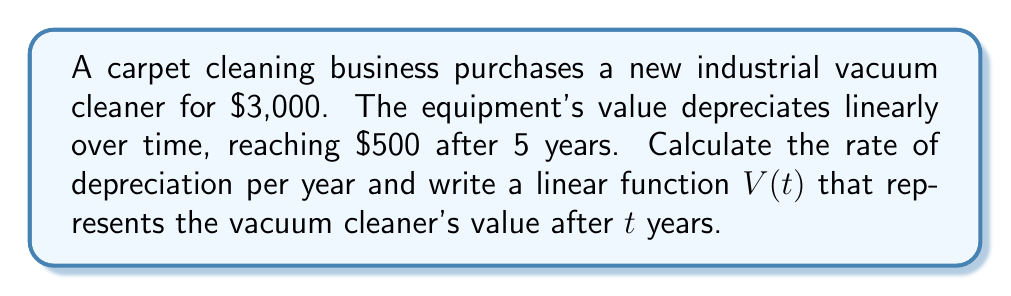Provide a solution to this math problem. 1. Identify the initial value and final value:
   Initial value (at $t=0$): $V_0 = $3,000
   Final value (at $t=5$): $V_5 = $500

2. Calculate the total depreciation:
   Total depreciation = $V_0 - V_5 = $3,000 - $500 = $2,500

3. Calculate the rate of depreciation per year:
   Rate = Total depreciation ÷ Number of years
   Rate = $2,500 ÷ 5 = $500 per year

4. Formulate the linear function:
   The general form of a linear function is $f(x) = mx + b$, where $m$ is the slope and $b$ is the y-intercept.
   In this case:
   - The slope $m$ is negative (as the value decreases) and equal to the depreciation rate: $m = -500$
   - The y-intercept $b$ is the initial value: $b = 3000$

   Therefore, the linear function is:
   $V(t) = -500t + 3000$

   Where $V(t)$ represents the vacuum cleaner's value after $t$ years.

5. Verify the function:
   At $t=0$: $V(0) = -500(0) + 3000 = 3000$
   At $t=5$: $V(5) = -500(5) + 3000 = 500$

   This confirms that the function correctly represents the depreciation over time.
Answer: Rate: $500/year; Function: $V(t) = -500t + 3000$ 